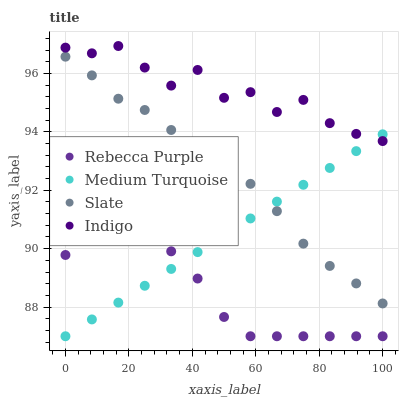Does Rebecca Purple have the minimum area under the curve?
Answer yes or no. Yes. Does Indigo have the maximum area under the curve?
Answer yes or no. Yes. Does Indigo have the minimum area under the curve?
Answer yes or no. No. Does Rebecca Purple have the maximum area under the curve?
Answer yes or no. No. Is Medium Turquoise the smoothest?
Answer yes or no. Yes. Is Indigo the roughest?
Answer yes or no. Yes. Is Rebecca Purple the smoothest?
Answer yes or no. No. Is Rebecca Purple the roughest?
Answer yes or no. No. Does Rebecca Purple have the lowest value?
Answer yes or no. Yes. Does Indigo have the lowest value?
Answer yes or no. No. Does Indigo have the highest value?
Answer yes or no. Yes. Does Rebecca Purple have the highest value?
Answer yes or no. No. Is Rebecca Purple less than Indigo?
Answer yes or no. Yes. Is Indigo greater than Rebecca Purple?
Answer yes or no. Yes. Does Medium Turquoise intersect Indigo?
Answer yes or no. Yes. Is Medium Turquoise less than Indigo?
Answer yes or no. No. Is Medium Turquoise greater than Indigo?
Answer yes or no. No. Does Rebecca Purple intersect Indigo?
Answer yes or no. No. 